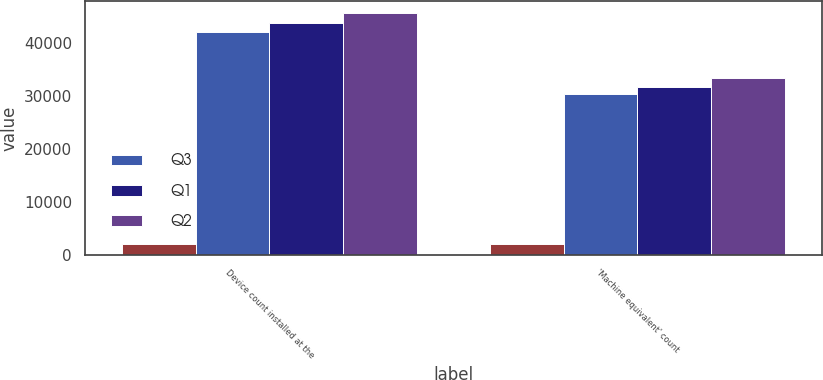Convert chart to OTSL. <chart><loc_0><loc_0><loc_500><loc_500><stacked_bar_chart><ecel><fcel>Device count installed at the<fcel>'Machine equivalent' count<nl><fcel>nan<fcel>2014<fcel>2014<nl><fcel>Q3<fcel>42153<fcel>30326<nl><fcel>Q1<fcel>43761<fcel>31713<nl><fcel>Q2<fcel>45596<fcel>33296<nl></chart> 